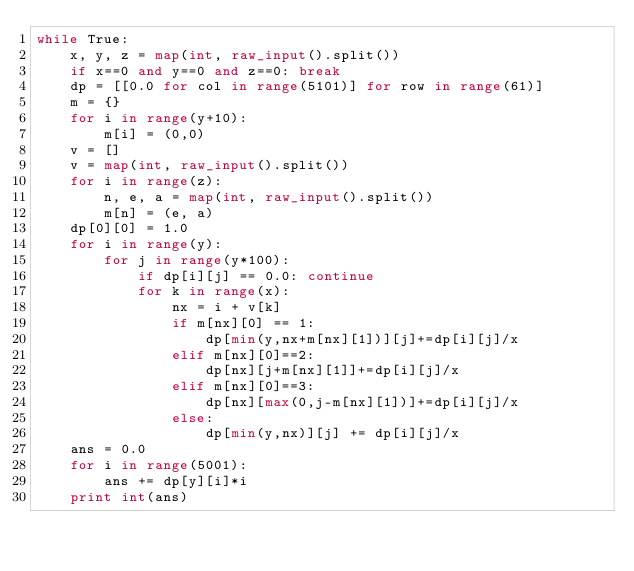<code> <loc_0><loc_0><loc_500><loc_500><_Python_>while True:
    x, y, z = map(int, raw_input().split())
    if x==0 and y==0 and z==0: break
    dp = [[0.0 for col in range(5101)] for row in range(61)]
    m = {}
    for i in range(y+10):
        m[i] = (0,0)
    v = []
    v = map(int, raw_input().split())
    for i in range(z):
        n, e, a = map(int, raw_input().split())
        m[n] = (e, a)
    dp[0][0] = 1.0
    for i in range(y):
        for j in range(y*100):
            if dp[i][j] == 0.0: continue
            for k in range(x):
                nx = i + v[k]
                if m[nx][0] == 1:
                    dp[min(y,nx+m[nx][1])][j]+=dp[i][j]/x
                elif m[nx][0]==2:
                    dp[nx][j+m[nx][1]]+=dp[i][j]/x
                elif m[nx][0]==3:
                    dp[nx][max(0,j-m[nx][1])]+=dp[i][j]/x
                else:
                    dp[min(y,nx)][j] += dp[i][j]/x                       
    ans = 0.0
    for i in range(5001):   
        ans += dp[y][i]*i
    print int(ans) </code> 